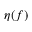<formula> <loc_0><loc_0><loc_500><loc_500>\eta ( f )</formula> 